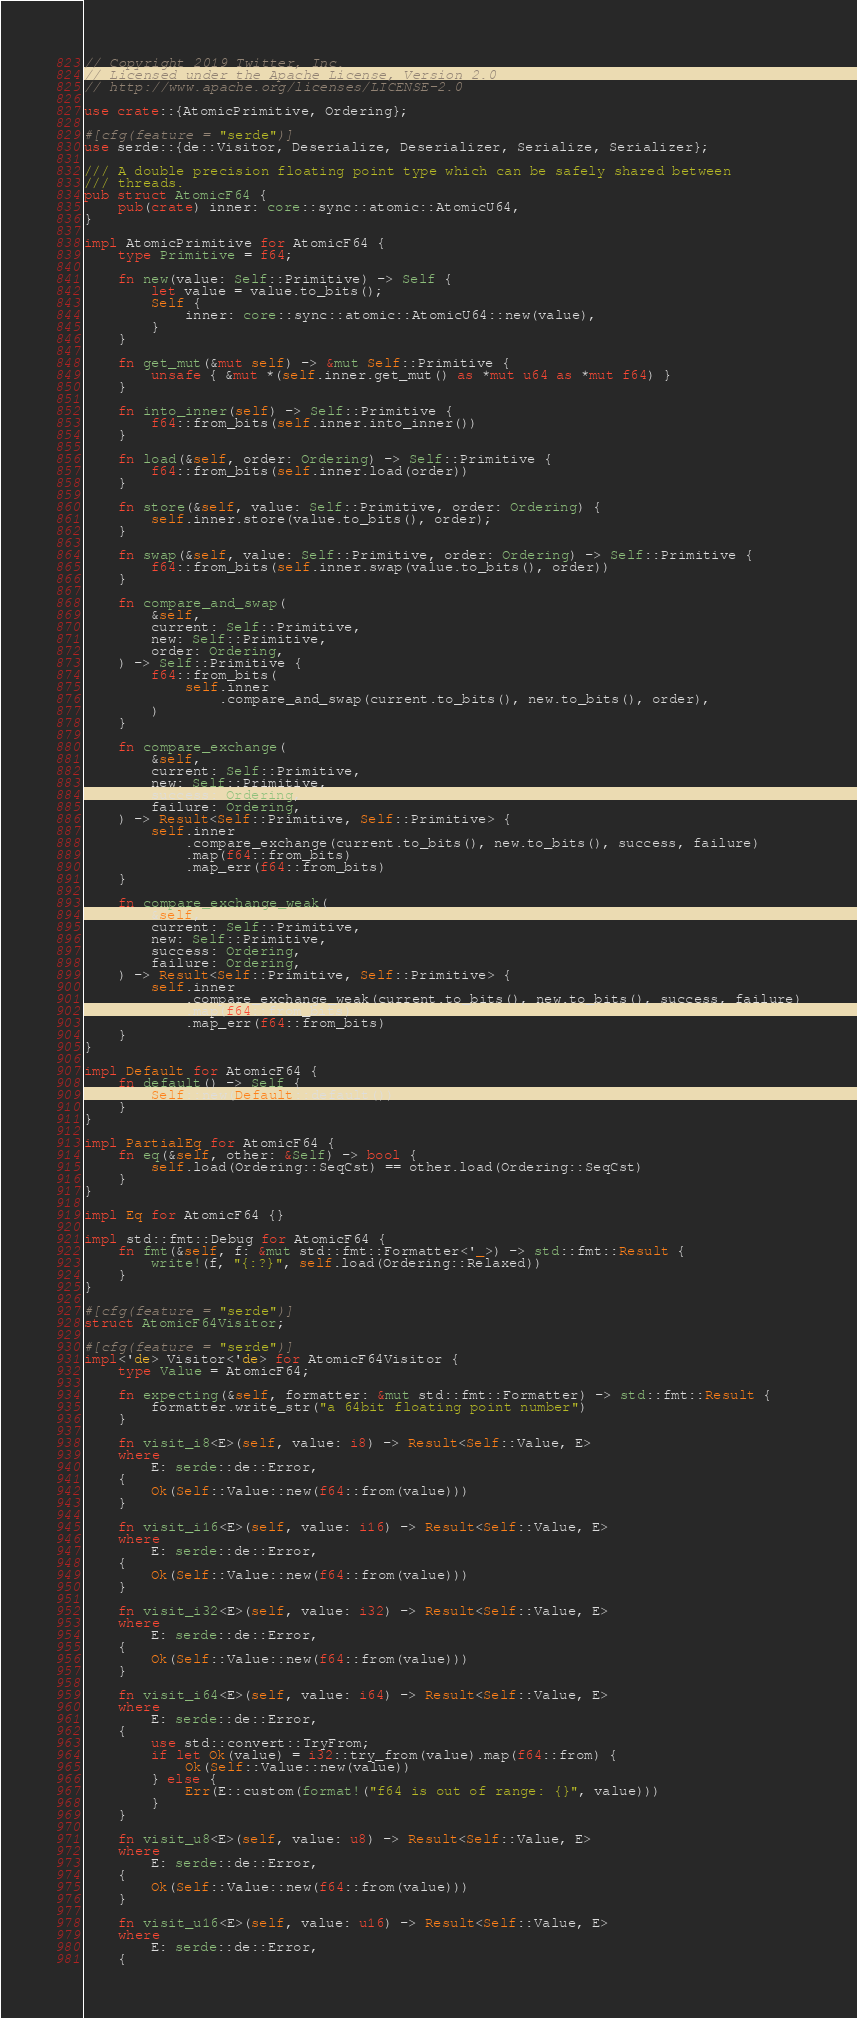<code> <loc_0><loc_0><loc_500><loc_500><_Rust_>// Copyright 2019 Twitter, Inc.
// Licensed under the Apache License, Version 2.0
// http://www.apache.org/licenses/LICENSE-2.0

use crate::{AtomicPrimitive, Ordering};

#[cfg(feature = "serde")]
use serde::{de::Visitor, Deserialize, Deserializer, Serialize, Serializer};

/// A double precision floating point type which can be safely shared between
/// threads.
pub struct AtomicF64 {
    pub(crate) inner: core::sync::atomic::AtomicU64,
}

impl AtomicPrimitive for AtomicF64 {
    type Primitive = f64;

    fn new(value: Self::Primitive) -> Self {
        let value = value.to_bits();
        Self {
            inner: core::sync::atomic::AtomicU64::new(value),
        }
    }

    fn get_mut(&mut self) -> &mut Self::Primitive {
        unsafe { &mut *(self.inner.get_mut() as *mut u64 as *mut f64) }
    }

    fn into_inner(self) -> Self::Primitive {
        f64::from_bits(self.inner.into_inner())
    }

    fn load(&self, order: Ordering) -> Self::Primitive {
        f64::from_bits(self.inner.load(order))
    }

    fn store(&self, value: Self::Primitive, order: Ordering) {
        self.inner.store(value.to_bits(), order);
    }

    fn swap(&self, value: Self::Primitive, order: Ordering) -> Self::Primitive {
        f64::from_bits(self.inner.swap(value.to_bits(), order))
    }

    fn compare_and_swap(
        &self,
        current: Self::Primitive,
        new: Self::Primitive,
        order: Ordering,
    ) -> Self::Primitive {
        f64::from_bits(
            self.inner
                .compare_and_swap(current.to_bits(), new.to_bits(), order),
        )
    }

    fn compare_exchange(
        &self,
        current: Self::Primitive,
        new: Self::Primitive,
        success: Ordering,
        failure: Ordering,
    ) -> Result<Self::Primitive, Self::Primitive> {
        self.inner
            .compare_exchange(current.to_bits(), new.to_bits(), success, failure)
            .map(f64::from_bits)
            .map_err(f64::from_bits)
    }

    fn compare_exchange_weak(
        &self,
        current: Self::Primitive,
        new: Self::Primitive,
        success: Ordering,
        failure: Ordering,
    ) -> Result<Self::Primitive, Self::Primitive> {
        self.inner
            .compare_exchange_weak(current.to_bits(), new.to_bits(), success, failure)
            .map(f64::from_bits)
            .map_err(f64::from_bits)
    }
}

impl Default for AtomicF64 {
    fn default() -> Self {
        Self::new(Default::default())
    }
}

impl PartialEq for AtomicF64 {
    fn eq(&self, other: &Self) -> bool {
        self.load(Ordering::SeqCst) == other.load(Ordering::SeqCst)
    }
}

impl Eq for AtomicF64 {}

impl std::fmt::Debug for AtomicF64 {
    fn fmt(&self, f: &mut std::fmt::Formatter<'_>) -> std::fmt::Result {
        write!(f, "{:?}", self.load(Ordering::Relaxed))
    }
}

#[cfg(feature = "serde")]
struct AtomicF64Visitor;

#[cfg(feature = "serde")]
impl<'de> Visitor<'de> for AtomicF64Visitor {
    type Value = AtomicF64;

    fn expecting(&self, formatter: &mut std::fmt::Formatter) -> std::fmt::Result {
        formatter.write_str("a 64bit floating point number")
    }

    fn visit_i8<E>(self, value: i8) -> Result<Self::Value, E>
    where
        E: serde::de::Error,
    {
        Ok(Self::Value::new(f64::from(value)))
    }

    fn visit_i16<E>(self, value: i16) -> Result<Self::Value, E>
    where
        E: serde::de::Error,
    {
        Ok(Self::Value::new(f64::from(value)))
    }

    fn visit_i32<E>(self, value: i32) -> Result<Self::Value, E>
    where
        E: serde::de::Error,
    {
        Ok(Self::Value::new(f64::from(value)))
    }

    fn visit_i64<E>(self, value: i64) -> Result<Self::Value, E>
    where
        E: serde::de::Error,
    {
        use std::convert::TryFrom;
        if let Ok(value) = i32::try_from(value).map(f64::from) {
            Ok(Self::Value::new(value))
        } else {
            Err(E::custom(format!("f64 is out of range: {}", value)))
        }
    }

    fn visit_u8<E>(self, value: u8) -> Result<Self::Value, E>
    where
        E: serde::de::Error,
    {
        Ok(Self::Value::new(f64::from(value)))
    }

    fn visit_u16<E>(self, value: u16) -> Result<Self::Value, E>
    where
        E: serde::de::Error,
    {</code> 